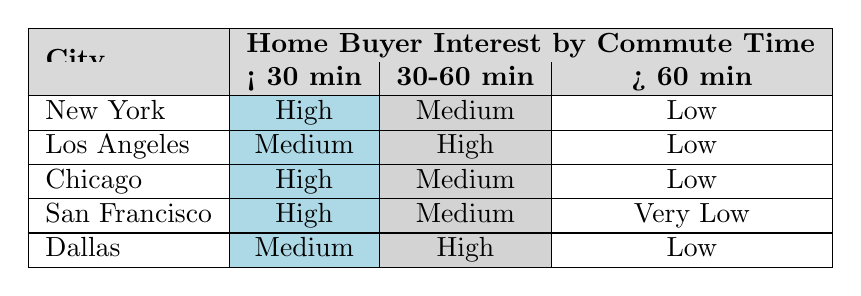What is the home buyer interest level for New York with a commute time of less than 30 minutes? The table shows that in New York, with a commute time of less than 30 minutes, the home buyer interest is categorized as High.
Answer: High Which city has the highest home buyer interest for a commute time of 30 to 60 minutes? According to the table, Los Angeles has the highest home buyer interest labeled as High for the 30 to 60 minutes commute time.
Answer: Los Angeles True or False: Dallas has a very low home buyer interest for a commute time of more than 60 minutes. The table indicates that for Dallas, the interest level for commute times over 60 minutes is Low, not Very Low; therefore, the statement is false.
Answer: False What is the total number of cities listed that have a High interest level for commute times less than 30 minutes? The cities with High interest for less than 30 minutes are New York, Chicago, and San Francisco, which totals three cities with this interest classification.
Answer: 3 If we consider the number of cities with Medium interest for commute times of 30 to 60 minutes, how many are there? The cities with Medium interest for 30 to 60 minutes are New York, Chicago, and San Francisco, which sums up to three cities.
Answer: 3 Which city has the lowest overall home buyer interest for commute times greater than 60 minutes? The table shows that San Francisco has the lowest category, indicating Very Low interest for commute times greater than 60 minutes.
Answer: San Francisco What is the difference in home buyer interest levels between the least favorable and most favorable commute time category for Chicago? Chicago has Low interest in the category of more than 60 minutes and High interest in the less than 30 minutes category. The difference in favorability is thus High (1) - Low (0) = 1 level difference.
Answer: 1 Which city has the same interest level (Medium) for the commute times of less than 30 minutes and 30 to 60 minutes? The table indicates that Los Angeles has a Medium interest level for less than 30 minutes and a High interest for 30 to 60 minutes, while Dallas has a Medium interest for less than 30 minutes and a High for 30 to 60 minutes as well. Thus, there’s no city with the same interest level for both categories.
Answer: None 